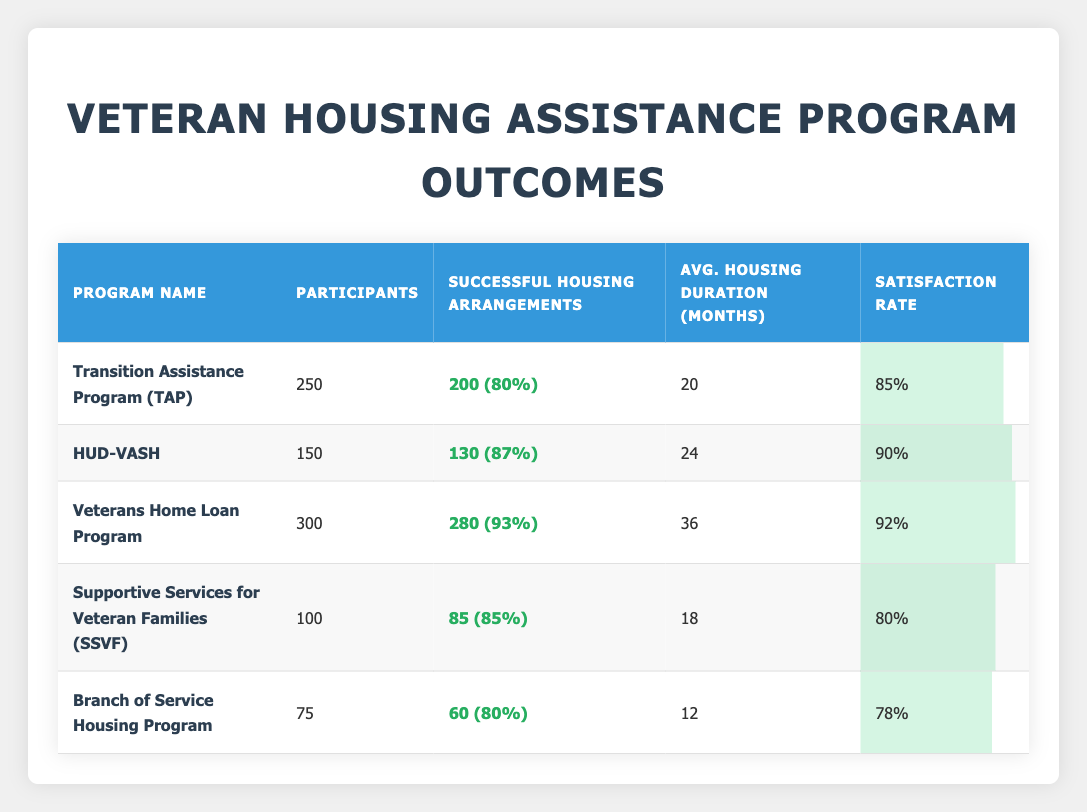What is the satisfaction rate of the Veterans Home Loan Program? The satisfaction rate for the Veterans Home Loan Program is listed in the table as 92%.
Answer: 92% How many participants were there in the Supportive Services for Veteran Families program? The number of participants in the Supportive Services for Veteran Families program is directly provided in the table as 100.
Answer: 100 Which program had the highest average housing duration, and what was that duration? The program with the highest average housing duration is the Veterans Home Loan Program with a duration of 36 months.
Answer: Veterans Home Loan Program; 36 months What is the total number of successful housing arrangements across all programs? To find the total successful housing arrangements, we sum the successful arrangements from all programs: 200 + 130 + 280 + 85 + 60 = 755.
Answer: 755 Is the satisfaction rate for the Branch of Service Housing Program greater than 75%? The satisfaction rate for the Branch of Service Housing Program is 78%, which is greater than 75%.
Answer: Yes What is the average satisfaction rate across all programs listed? To calculate the average satisfaction rate, we add the satisfaction rates: 85 + 90 + 92 + 80 + 78 = 425, then divide by the number of programs (5), which gives us 425/5 = 85.
Answer: 85 Which program had the lowest successful housing arrangements and what percentage of participants were successful? The program with the lowest successful housing arrangements is the Branch of Service Housing Program with 60 successful arrangements out of 75 participants, giving a success percentage of 80%.
Answer: Branch of Service Housing Program; 80% How many programs have a satisfaction rate of 85% or higher? The satisfaction rates of the programs are: TAP (85%), HUD-VASH (90%), Veterans Home Loan Program (92%), SSVF (80%), and Branch (78%). Thus, the programs with at least 85% satisfaction are TAP, HUD-VASH, and Veterans Home Loan Program, totaling 3 programs.
Answer: 3 